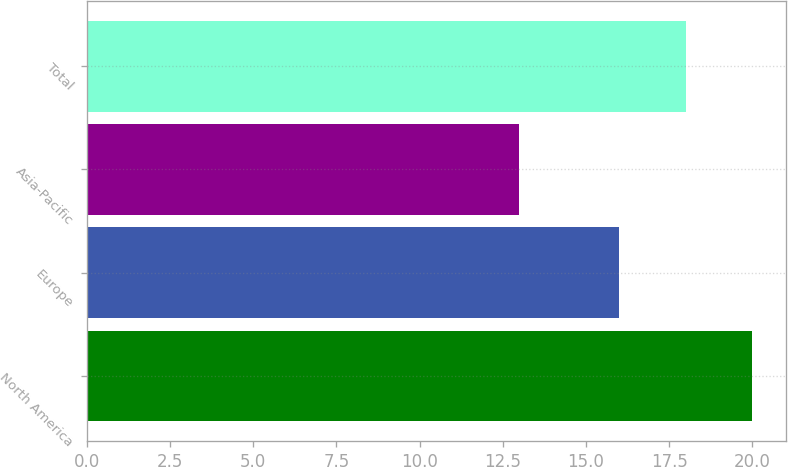Convert chart. <chart><loc_0><loc_0><loc_500><loc_500><bar_chart><fcel>North America<fcel>Europe<fcel>Asia-Pacific<fcel>Total<nl><fcel>20<fcel>16<fcel>13<fcel>18<nl></chart> 